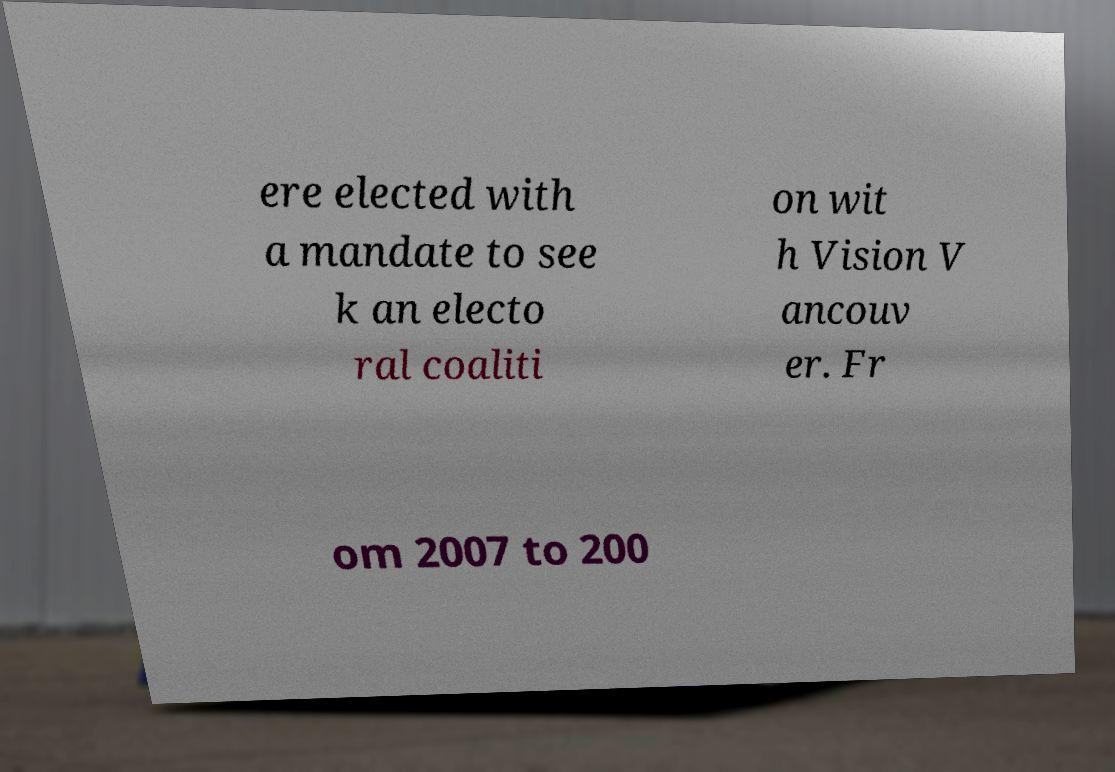I need the written content from this picture converted into text. Can you do that? ere elected with a mandate to see k an electo ral coaliti on wit h Vision V ancouv er. Fr om 2007 to 200 